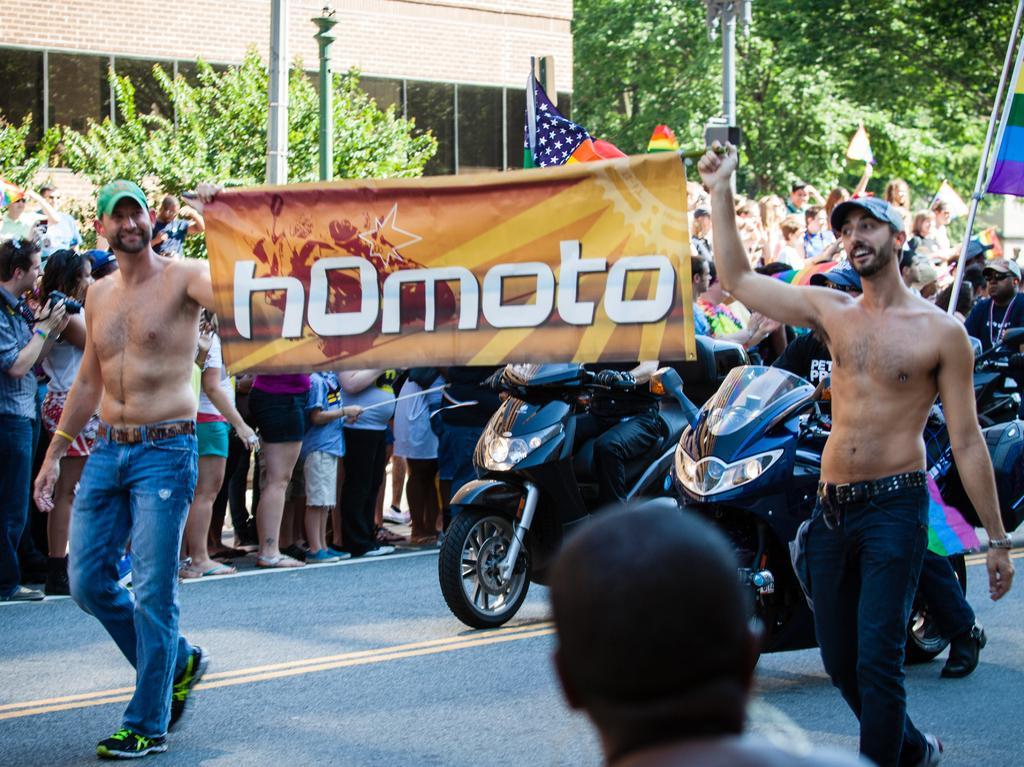Could you give a brief overview of what you see in this image? There are people around, these two are catching a poster in their hands and wearing cap back of them there are two bikes. There is a building behind and many trees. 